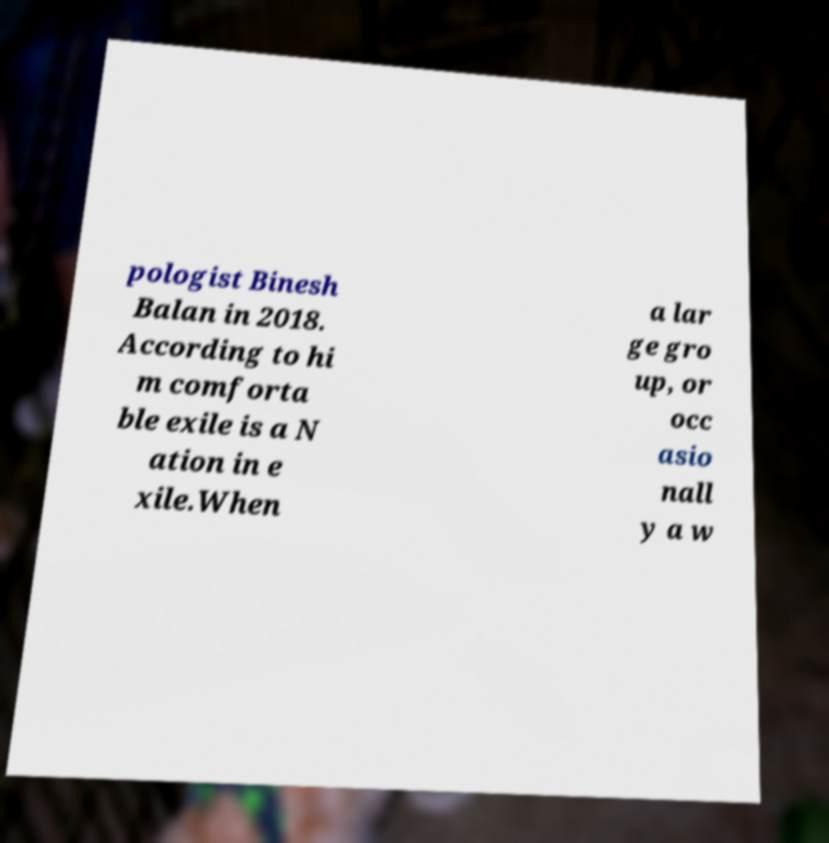Can you accurately transcribe the text from the provided image for me? pologist Binesh Balan in 2018. According to hi m comforta ble exile is a N ation in e xile.When a lar ge gro up, or occ asio nall y a w 